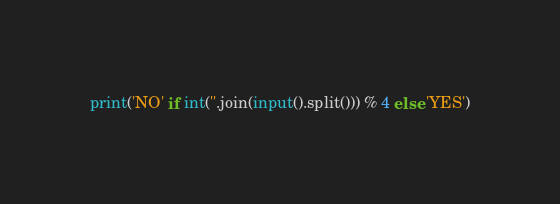<code> <loc_0><loc_0><loc_500><loc_500><_Python_>print('NO' if int(''.join(input().split())) % 4 else 'YES')</code> 